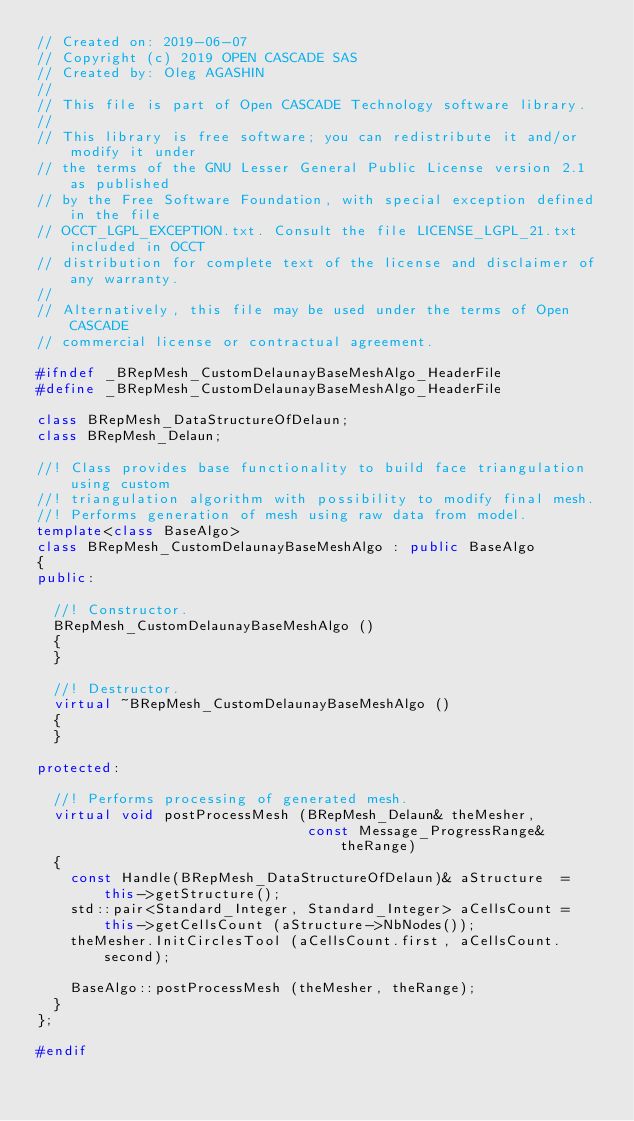Convert code to text. <code><loc_0><loc_0><loc_500><loc_500><_C++_>// Created on: 2019-06-07
// Copyright (c) 2019 OPEN CASCADE SAS
// Created by: Oleg AGASHIN
//
// This file is part of Open CASCADE Technology software library.
//
// This library is free software; you can redistribute it and/or modify it under
// the terms of the GNU Lesser General Public License version 2.1 as published
// by the Free Software Foundation, with special exception defined in the file
// OCCT_LGPL_EXCEPTION.txt. Consult the file LICENSE_LGPL_21.txt included in OCCT
// distribution for complete text of the license and disclaimer of any warranty.
//
// Alternatively, this file may be used under the terms of Open CASCADE
// commercial license or contractual agreement.

#ifndef _BRepMesh_CustomDelaunayBaseMeshAlgo_HeaderFile
#define _BRepMesh_CustomDelaunayBaseMeshAlgo_HeaderFile

class BRepMesh_DataStructureOfDelaun;
class BRepMesh_Delaun;

//! Class provides base functionality to build face triangulation using custom
//! triangulation algorithm with possibility to modify final mesh.
//! Performs generation of mesh using raw data from model.
template<class BaseAlgo>
class BRepMesh_CustomDelaunayBaseMeshAlgo : public BaseAlgo
{
public:

  //! Constructor.
  BRepMesh_CustomDelaunayBaseMeshAlgo ()
  {
  } 

  //! Destructor.
  virtual ~BRepMesh_CustomDelaunayBaseMeshAlgo ()
  {
  }

protected:

  //! Performs processing of generated mesh.
  virtual void postProcessMesh (BRepMesh_Delaun& theMesher,
                                const Message_ProgressRange& theRange)
  {
    const Handle(BRepMesh_DataStructureOfDelaun)& aStructure  = this->getStructure();
    std::pair<Standard_Integer, Standard_Integer> aCellsCount = this->getCellsCount (aStructure->NbNodes());
    theMesher.InitCirclesTool (aCellsCount.first, aCellsCount.second);

    BaseAlgo::postProcessMesh (theMesher, theRange);
  }
};

#endif
</code> 